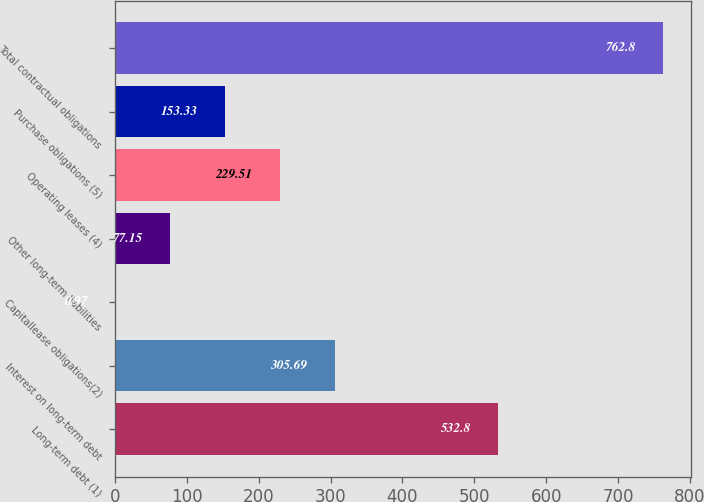<chart> <loc_0><loc_0><loc_500><loc_500><bar_chart><fcel>Long-term debt (1)<fcel>Interest on long-term debt<fcel>Capitallease obligations(2)<fcel>Other long-term liabilities<fcel>Operating leases (4)<fcel>Purchase obligations (5)<fcel>Total contractual obligations<nl><fcel>532.8<fcel>305.69<fcel>0.97<fcel>77.15<fcel>229.51<fcel>153.33<fcel>762.8<nl></chart> 